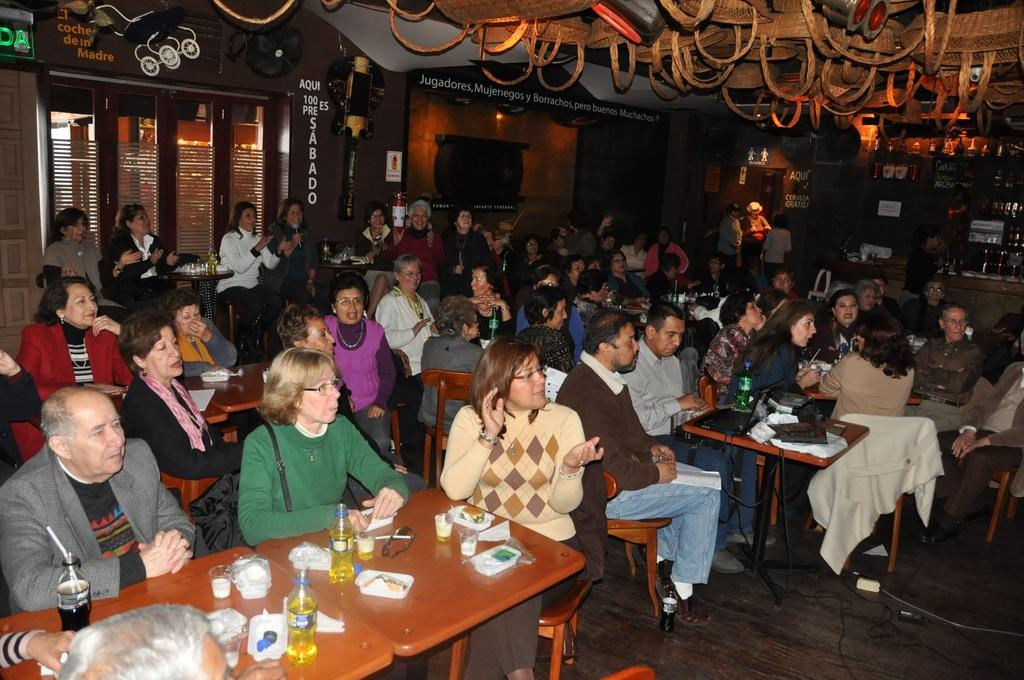What are the people in the image doing? The people in the image are sitting on chairs. What furniture is present in the image besides chairs? There are tables in the image. What can be seen on the tables? There are bottles on the tables. Are there any other items on the tables besides bottles? Yes, there are additional items on the tables. What type of bird is sitting on the cake in the image? There is no bird or cake present in the image. How many tomatoes are visible on the tables in the image? There are no tomatoes visible in the image. 